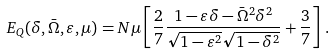Convert formula to latex. <formula><loc_0><loc_0><loc_500><loc_500>E _ { Q } ( \delta , \bar { \Omega } , \varepsilon , \mu ) = N \mu \left [ \frac { 2 } { 7 } \frac { 1 - \varepsilon \delta - \bar { \Omega } ^ { 2 } \delta ^ { 2 } } { \sqrt { 1 - \varepsilon ^ { 2 } } \sqrt { 1 - \delta ^ { 2 } } } + \frac { 3 } { 7 } \right ] \, .</formula> 